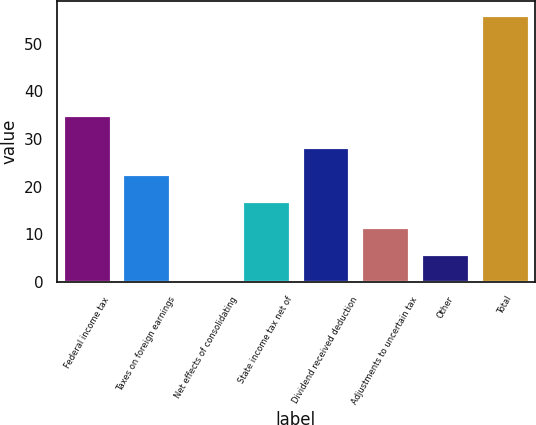<chart> <loc_0><loc_0><loc_500><loc_500><bar_chart><fcel>Federal income tax<fcel>Taxes on foreign earnings<fcel>Net effects of consolidating<fcel>State income tax net of<fcel>Dividend received deduction<fcel>Adjustments to uncertain tax<fcel>Other<fcel>Total<nl><fcel>35<fcel>22.62<fcel>0.3<fcel>17.04<fcel>28.2<fcel>11.46<fcel>5.88<fcel>56.1<nl></chart> 